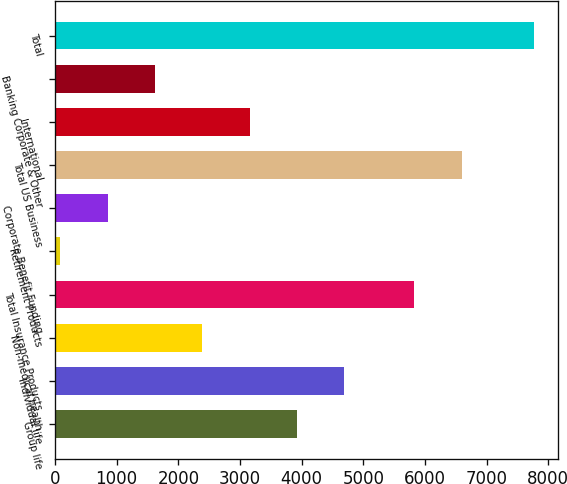<chart> <loc_0><loc_0><loc_500><loc_500><bar_chart><fcel>Group life<fcel>Individual life<fcel>Non-medical health<fcel>Total Insurance Products<fcel>Retirement Products<fcel>Corporate Benefit Funding<fcel>Total US Business<fcel>International<fcel>Banking Corporate & Other<fcel>Total<nl><fcel>3925<fcel>4692.4<fcel>2390.2<fcel>5826<fcel>88<fcel>855.4<fcel>6593.4<fcel>3157.6<fcel>1622.8<fcel>7762<nl></chart> 